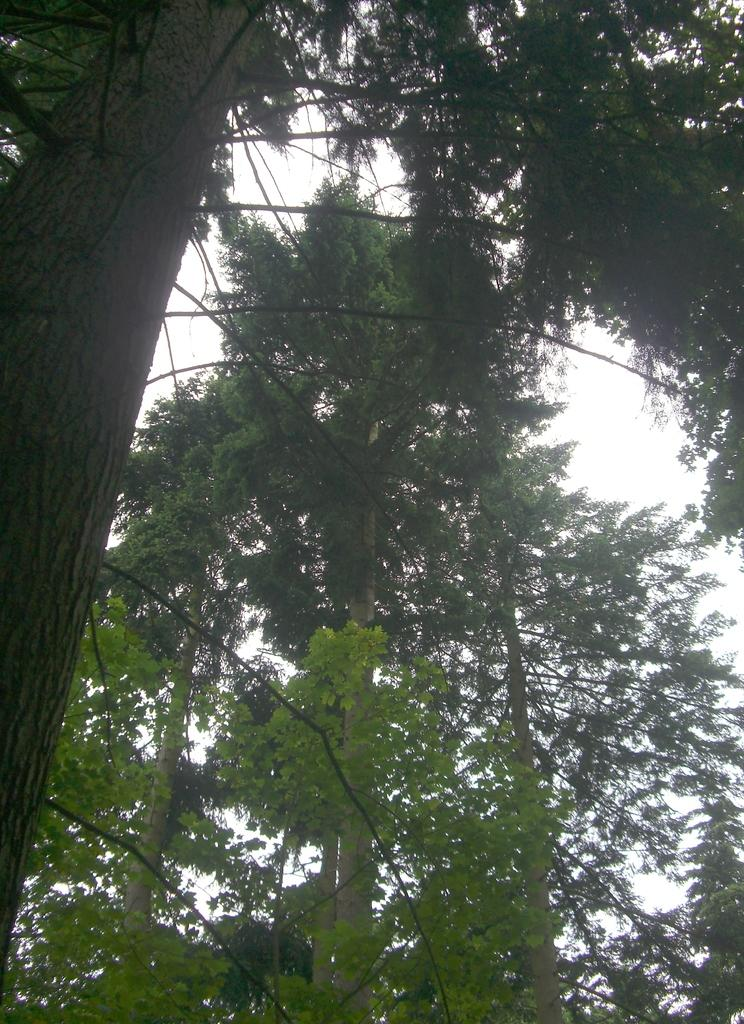Where was the image taken? The image was taken outdoors. What can be seen in the background of the image? The sky is visible in the background of the image. What type of vegetation is present in the image? There are many trees in the image. Can you describe the trees in the image? The trees have leaves, stems, and branches. How many cats are sitting on the branches of the trees in the image? There are no cats present in the image; it features trees with leaves, stems, and branches. What type of development project is being discussed in the image? There is no development project or discussion present in the image; it is a photograph of trees and the sky. 